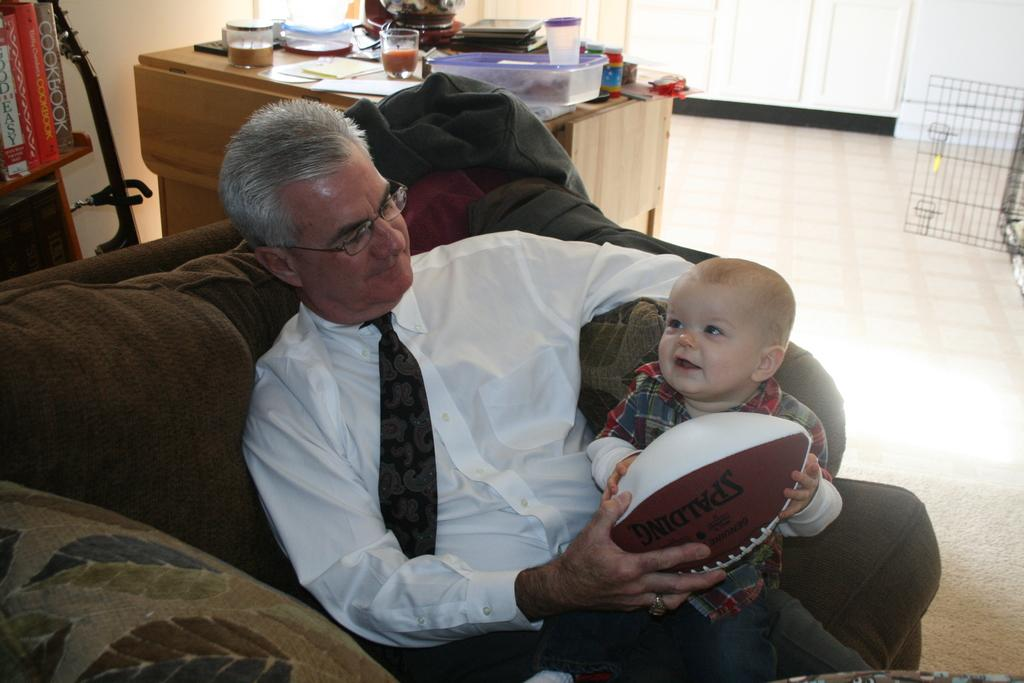What is the man doing in the image? The man is seated on the sofa and holding a boy in his hands. What else is the man holding in his hands? The man is also holding a ball in his hands. What can be seen in the background of the image? There are boxes, glasses, and books on a table in the background of the image. Can you see a squirrel holding a nut in the image? No, there is no squirrel or nut present in the image. What type of receipt is visible on the table in the image? There is no receipt visible on the table in the image. 